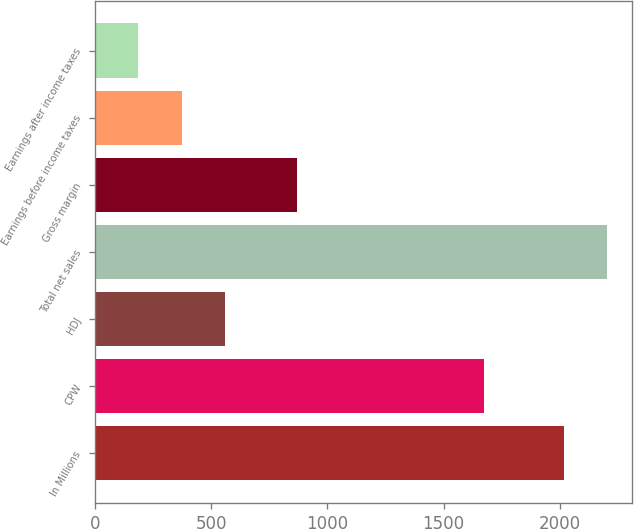Convert chart. <chart><loc_0><loc_0><loc_500><loc_500><bar_chart><fcel>In Millions<fcel>CPW<fcel>HDJ<fcel>Total net sales<fcel>Gross margin<fcel>Earnings before income taxes<fcel>Earnings after income taxes<nl><fcel>2016<fcel>1674.8<fcel>558.2<fcel>2201.75<fcel>867.6<fcel>372.45<fcel>186.7<nl></chart> 